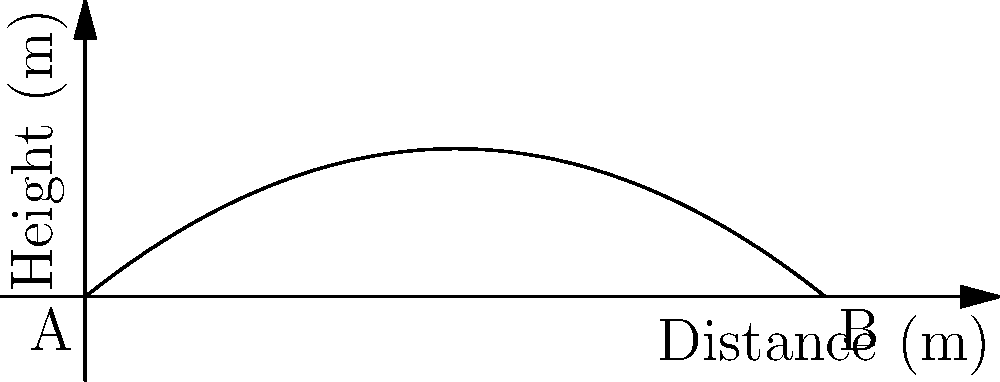During a historical reenactment, an artillery shell is fired from point A and follows the trajectory shown in the graph. The trajectory is modeled by the equation $h(x) = -0.005x^2 + 0.8x$, where $h$ is the height in meters and $x$ is the horizontal distance in meters. What is the maximum height reached by the shell? To find the maximum height of the trajectory, we need to follow these steps:

1) The maximum height occurs at the vertex of the parabola.

2) For a quadratic function in the form $f(x) = ax^2 + bx + c$, the x-coordinate of the vertex is given by $x = -\frac{b}{2a}$.

3) In our equation $h(x) = -0.005x^2 + 0.8x$, we have:
   $a = -0.005$
   $b = 0.8$

4) Plugging these values into the formula:
   $x = -\frac{0.8}{2(-0.005)} = -\frac{0.8}{-0.01} = 80$ meters

5) To find the maximum height, we need to calculate $h(80)$:
   $h(80) = -0.005(80)^2 + 0.8(80)$
   $= -0.005(6400) + 64$
   $= -32 + 64$
   $= 32$ meters

Therefore, the maximum height reached by the shell is 32 meters.
Answer: 32 meters 